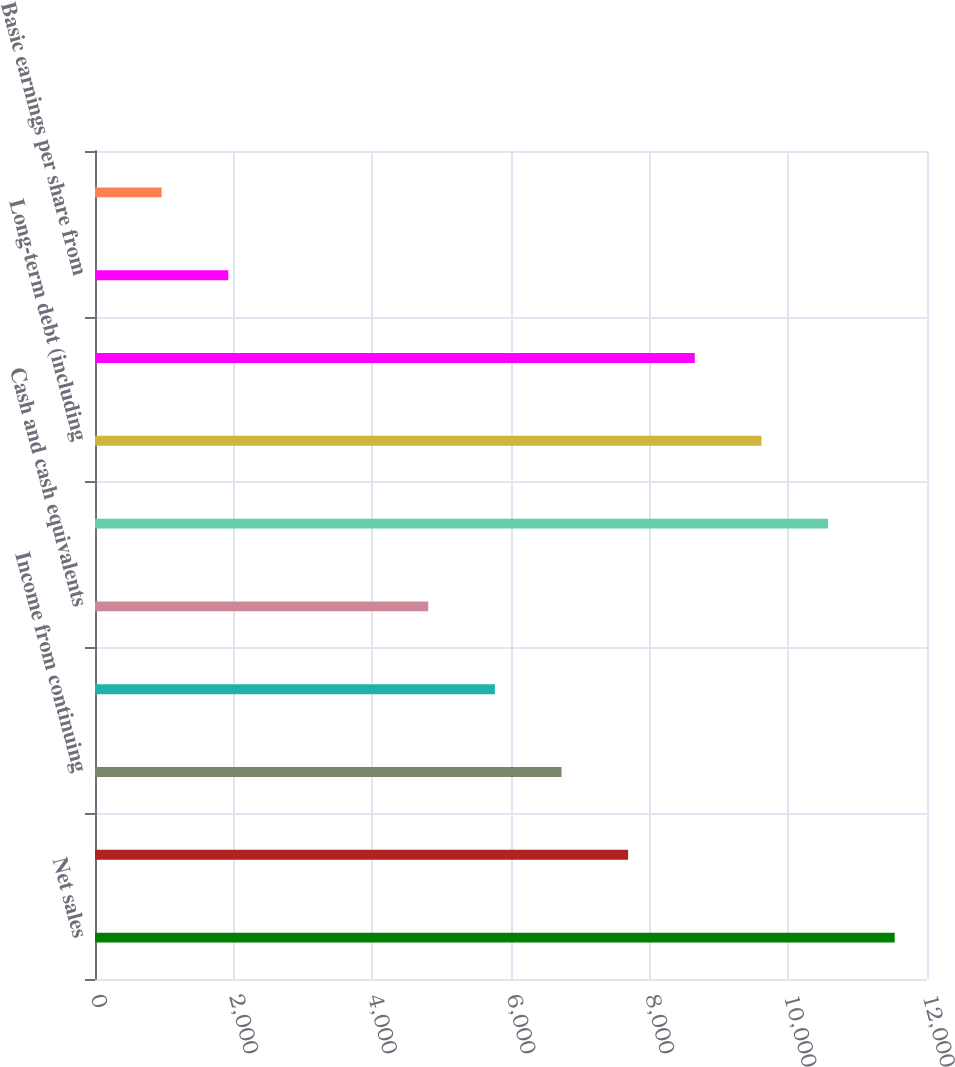Convert chart. <chart><loc_0><loc_0><loc_500><loc_500><bar_chart><fcel>Net sales<fcel>Operating income<fcel>Income from continuing<fcel>Net income attributable to<fcel>Cash and cash equivalents<fcel>Total assets<fcel>Long-term debt (including<fcel>Total shareholder' equity<fcel>Basic earnings per share from<fcel>Diluted earnings per share<nl><fcel>11534.1<fcel>7689.52<fcel>6728.38<fcel>5767.24<fcel>4806.1<fcel>10572.9<fcel>9611.8<fcel>8650.66<fcel>1922.68<fcel>961.54<nl></chart> 